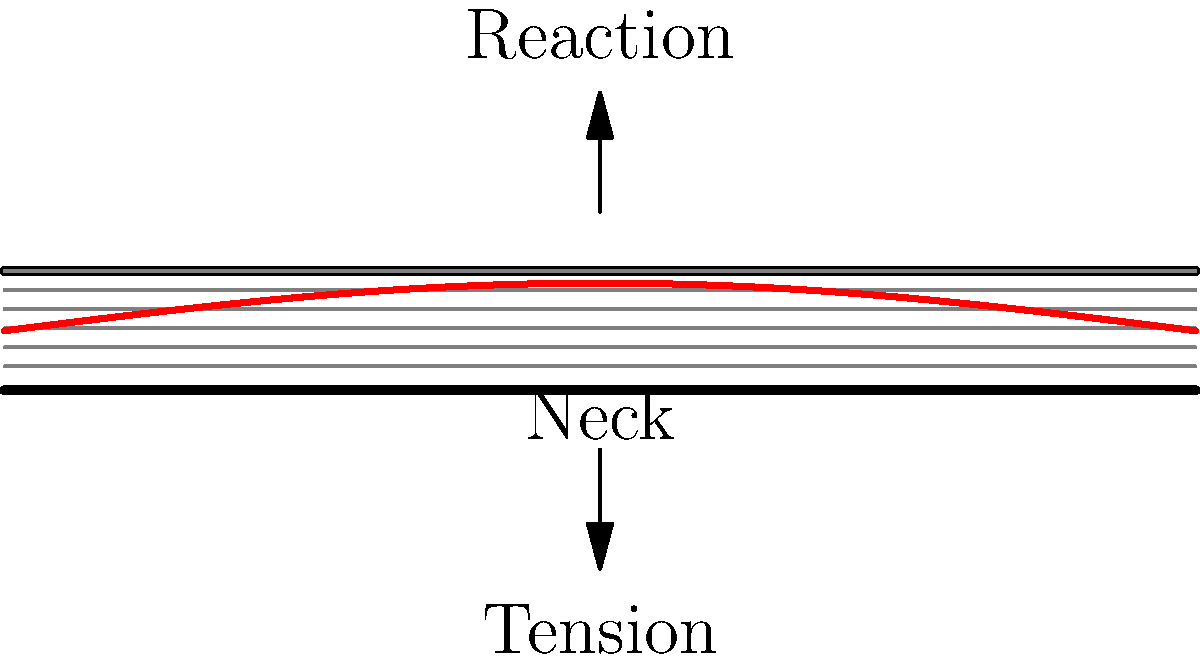In Harry Styles' acoustic guitar, the neck experiences bending stress due to string tension. Assuming the neck behaves like a simply supported beam with a distributed load, what shape would the bending stress distribution along the length of the neck most likely resemble? To understand the stress distribution in Harry Styles' guitar neck, let's break it down step-by-step:

1. Guitar string tension creates a distributed load along the neck.
2. The neck can be modeled as a simply supported beam:
   - Fixed at the body end
   - Supported (but not fixed) at the headstock end

3. For a simply supported beam with a uniform distributed load:
   - The bending moment equation is: $M(x) = \frac{wL}{2}x - \frac{w}{2}x^2$
   where $w$ is the distributed load, $L$ is the length, and $x$ is the position along the beam.

4. The bending stress is proportional to the bending moment:
   $\sigma = \frac{My}{I}$
   where $y$ is the distance from the neutral axis, and $I$ is the moment of inertia.

5. Substituting the moment equation:
   $\sigma \propto \frac{wL}{2}x - \frac{w}{2}x^2$

6. This equation represents a parabolic distribution with:
   - Zero stress at the ends (x = 0 and x = L)
   - Maximum stress at the center (x = L/2)

7. The resulting stress distribution along the length of the neck resembles a parabolic or sine-like curve.

In the context of Harry Styles' guitar, this means the middle of the neck experiences the highest bending stress, while the ends (near the body and the headstock) experience minimal bending stress.
Answer: Parabolic or sine-like curve 